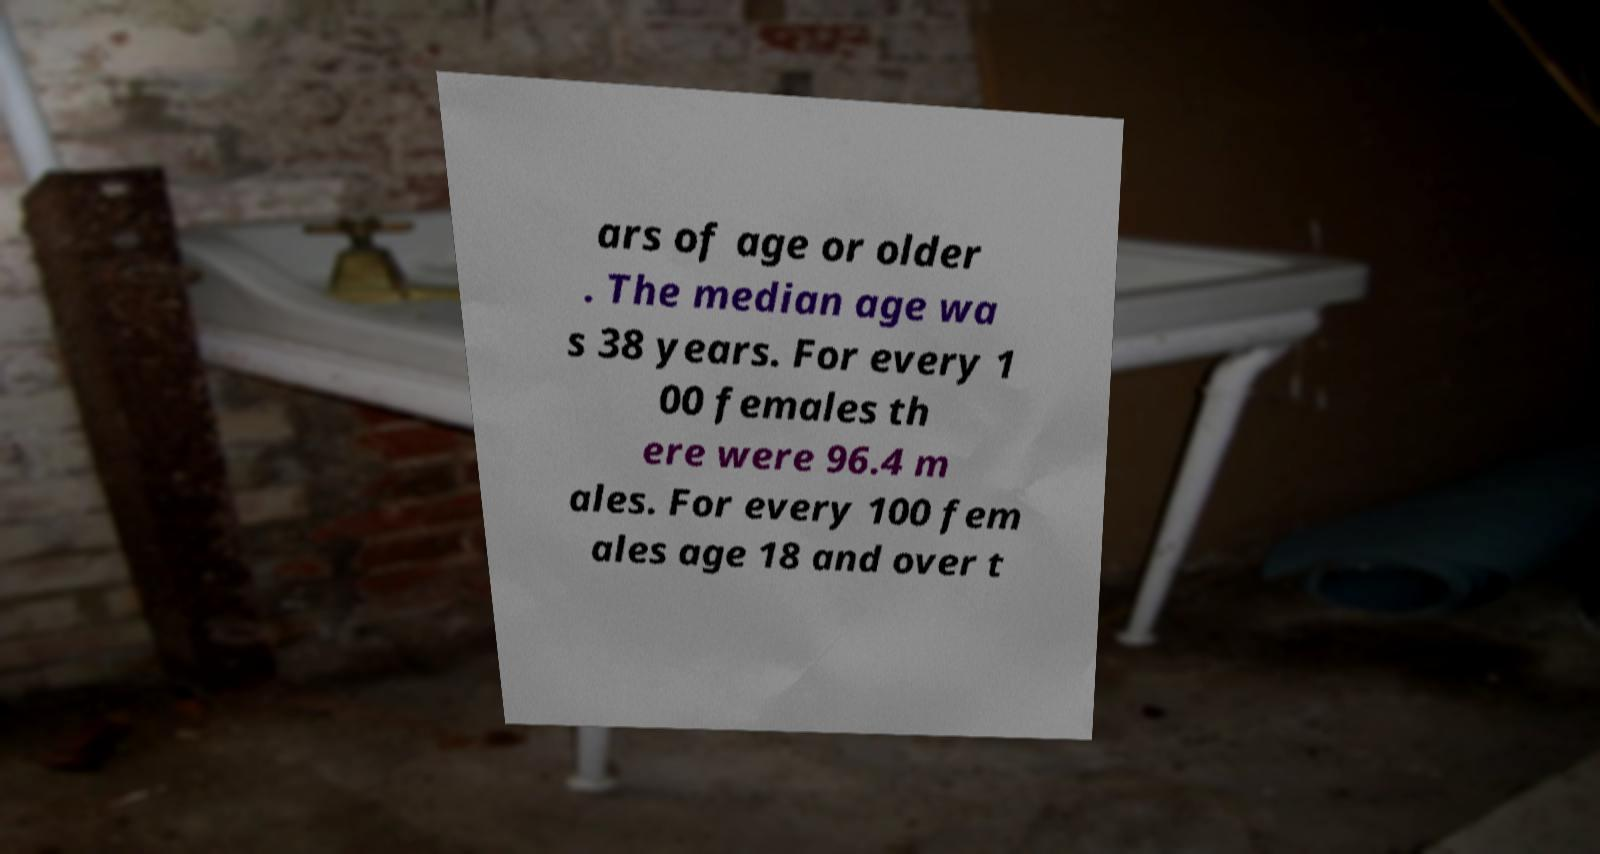Please identify and transcribe the text found in this image. ars of age or older . The median age wa s 38 years. For every 1 00 females th ere were 96.4 m ales. For every 100 fem ales age 18 and over t 